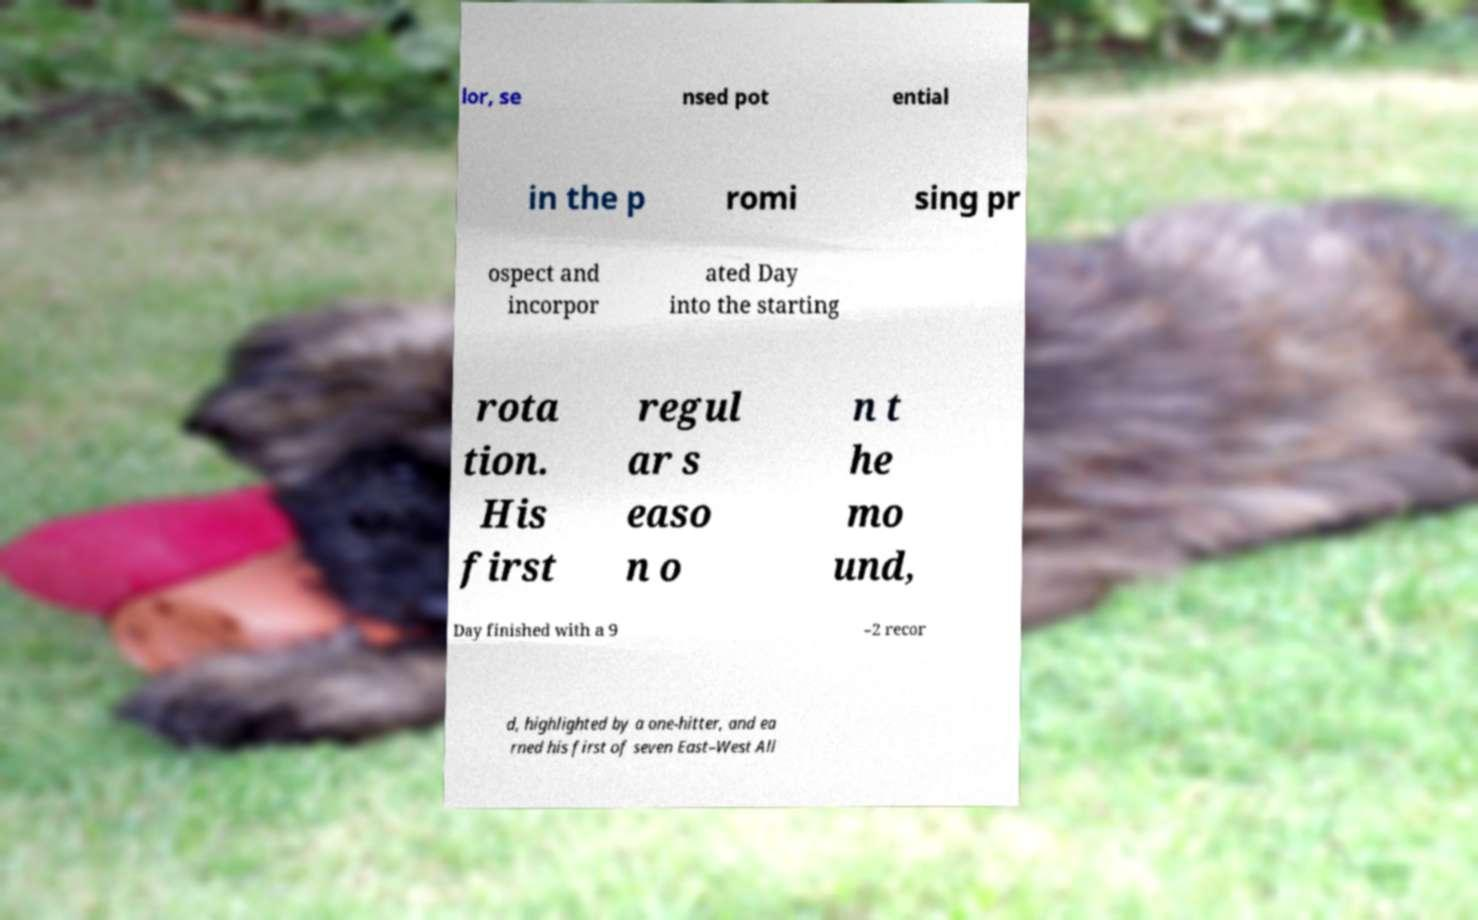Can you read and provide the text displayed in the image?This photo seems to have some interesting text. Can you extract and type it out for me? lor, se nsed pot ential in the p romi sing pr ospect and incorpor ated Day into the starting rota tion. His first regul ar s easo n o n t he mo und, Day finished with a 9 –2 recor d, highlighted by a one-hitter, and ea rned his first of seven East–West All 